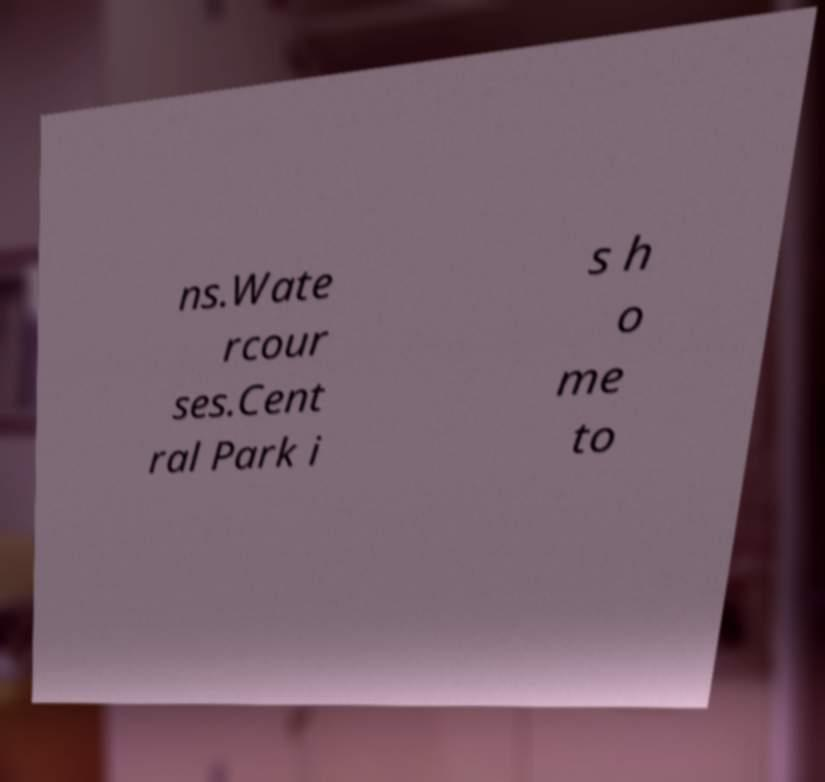For documentation purposes, I need the text within this image transcribed. Could you provide that? ns.Wate rcour ses.Cent ral Park i s h o me to 